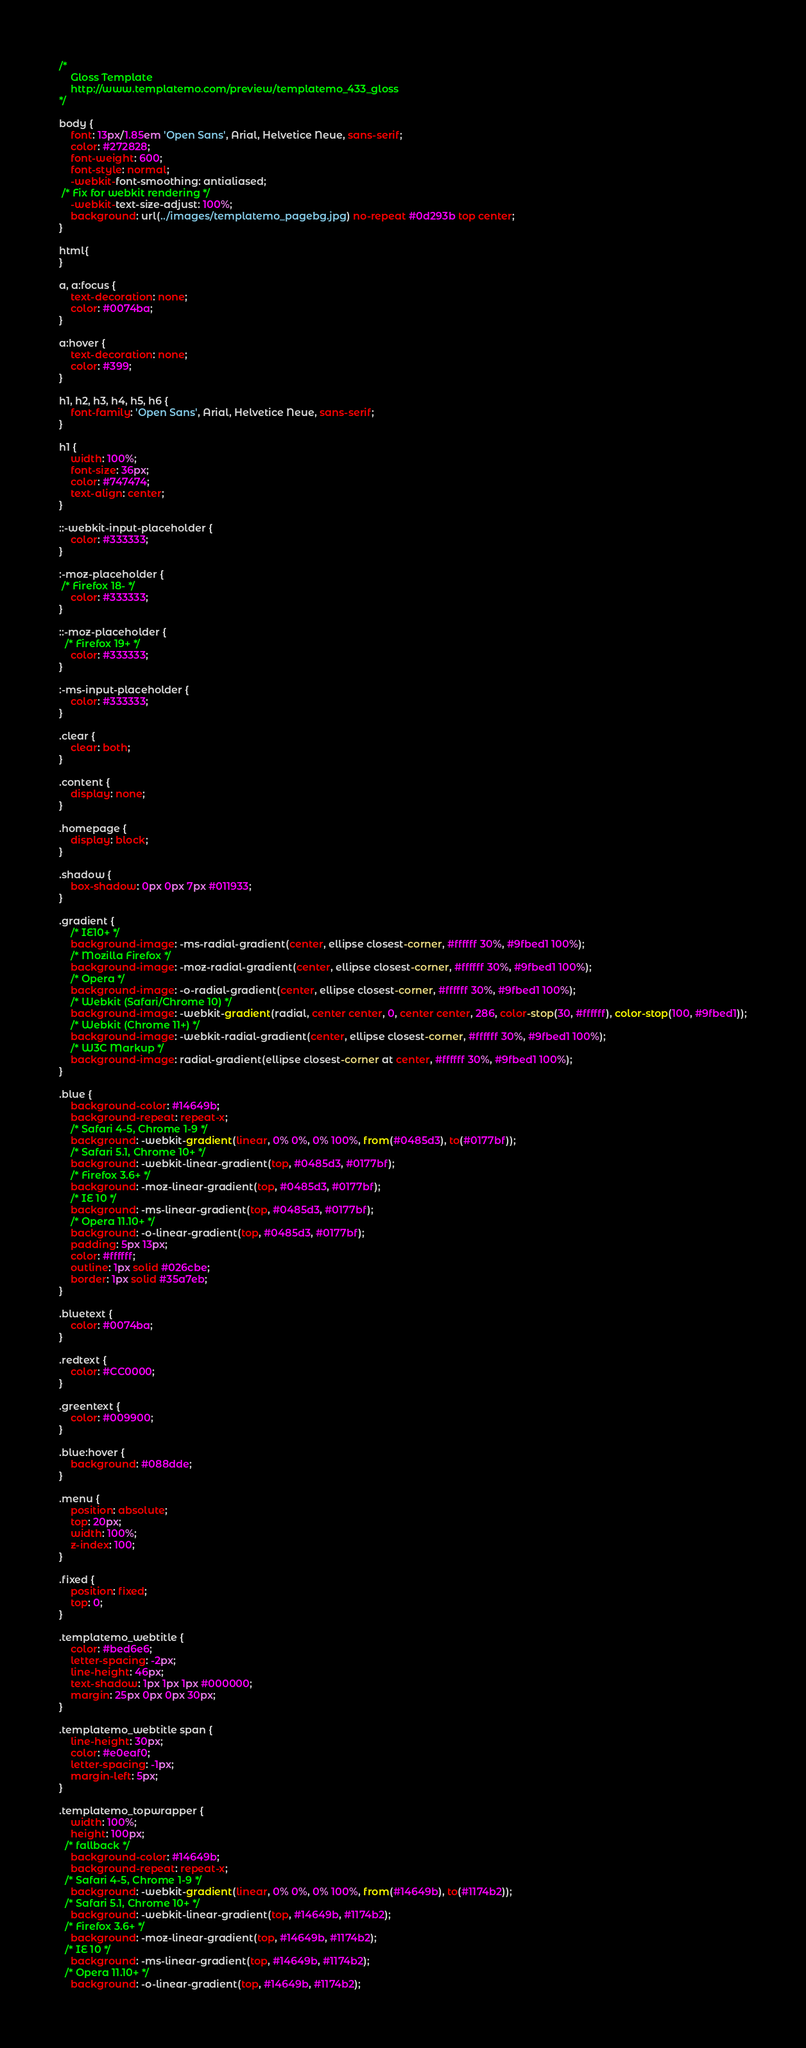<code> <loc_0><loc_0><loc_500><loc_500><_CSS_>/*
	Gloss Template
	http://www.templatemo.com/preview/templatemo_433_gloss	
*/

body {
    font: 13px/1.85em 'Open Sans', Arial, Helvetice Neue, sans-serif;
    color: #272828;
    font-weight: 600;
    font-style: normal;
    -webkit-font-smoothing: antialiased;
 /* Fix for webkit rendering */
    -webkit-text-size-adjust: 100%;
    background: url(../images/templatemo_pagebg.jpg) no-repeat #0d293b top center;
}

html{
}

a, a:focus {
    text-decoration: none;
    color: #0074ba;
}

a:hover {
    text-decoration: none;
    color: #399;
}

h1, h2, h3, h4, h5, h6 {
    font-family: 'Open Sans', Arial, Helvetice Neue, sans-serif;
}

h1 {
    width: 100%;
    font-size: 36px;
    color: #747474;
    text-align: center;
}

::-webkit-input-placeholder {
    color: #333333;
}

:-moz-placeholder {
 /* Firefox 18- */
    color: #333333;
}

::-moz-placeholder {
  /* Firefox 19+ */
    color: #333333;
}

:-ms-input-placeholder {
    color: #333333;
}

.clear {
    clear: both;
}

.content {
    display: none;
}

.homepage {
    display: block;
}

.shadow {
    box-shadow: 0px 0px 7px #011933;
}

.gradient {
	/* IE10+ */
    background-image: -ms-radial-gradient(center, ellipse closest-corner, #ffffff 30%, #9fbed1 100%);
	/* Mozilla Firefox */
    background-image: -moz-radial-gradient(center, ellipse closest-corner, #ffffff 30%, #9fbed1 100%);
	/* Opera */
    background-image: -o-radial-gradient(center, ellipse closest-corner, #ffffff 30%, #9fbed1 100%);
	/* Webkit (Safari/Chrome 10) */
    background-image: -webkit-gradient(radial, center center, 0, center center, 286, color-stop(30, #ffffff), color-stop(100, #9fbed1));
	/* Webkit (Chrome 11+) */
    background-image: -webkit-radial-gradient(center, ellipse closest-corner, #ffffff 30%, #9fbed1 100%);
	/* W3C Markup */
    background-image: radial-gradient(ellipse closest-corner at center, #ffffff 30%, #9fbed1 100%);
}

.blue {
    background-color: #14649b;
    background-repeat: repeat-x;
	/* Safari 4-5, Chrome 1-9 */
    background: -webkit-gradient(linear, 0% 0%, 0% 100%, from(#0485d3), to(#0177bf));
	/* Safari 5.1, Chrome 10+ */
    background: -webkit-linear-gradient(top, #0485d3, #0177bf);
	/* Firefox 3.6+ */
    background: -moz-linear-gradient(top, #0485d3, #0177bf);
	/* IE 10 */
    background: -ms-linear-gradient(top, #0485d3, #0177bf);
	/* Opera 11.10+ */
    background: -o-linear-gradient(top, #0485d3, #0177bf);
    padding: 5px 13px;
    color: #ffffff;
    outline: 1px solid #026cbe;
    border: 1px solid #35a7eb;
}

.bluetext {
    color: #0074ba;
}

.redtext {
    color: #CC0000;
}

.greentext {
    color: #009900;
}

.blue:hover {
    background: #088dde;
}

.menu {
    position: absolute;
    top: 20px;
    width: 100%;
    z-index: 100;
}

.fixed {
    position: fixed;
    top: 0;
}

.templatemo_webtitle {
    color: #bed6e6;
    letter-spacing: -2px;
    line-height: 46px;
    text-shadow: 1px 1px 1px #000000;
    margin: 25px 0px 0px 30px;
}

.templatemo_webtitle span {
    line-height: 30px;
    color: #e0eaf0;
    letter-spacing: -1px;
    margin-left: 5px;
}

.templatemo_topwrapper {
    width: 100%;
    height: 100px;
  /* fallback */
    background-color: #14649b;
    background-repeat: repeat-x;
  /* Safari 4-5, Chrome 1-9 */
    background: -webkit-gradient(linear, 0% 0%, 0% 100%, from(#14649b), to(#1174b2));
  /* Safari 5.1, Chrome 10+ */
    background: -webkit-linear-gradient(top, #14649b, #1174b2);
  /* Firefox 3.6+ */
    background: -moz-linear-gradient(top, #14649b, #1174b2);
  /* IE 10 */
    background: -ms-linear-gradient(top, #14649b, #1174b2);
  /* Opera 11.10+ */
    background: -o-linear-gradient(top, #14649b, #1174b2);</code> 